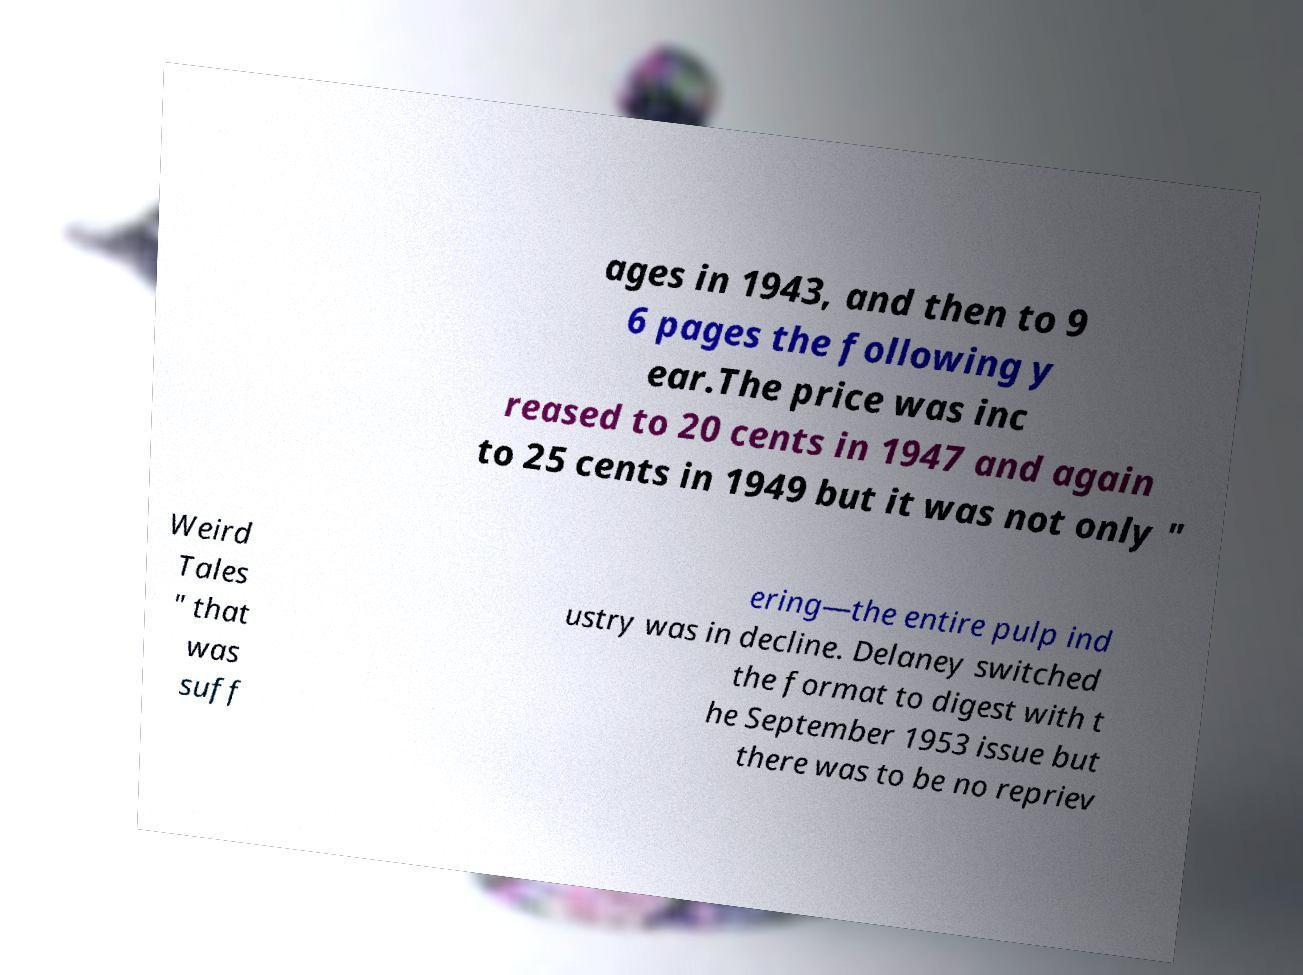Can you read and provide the text displayed in the image?This photo seems to have some interesting text. Can you extract and type it out for me? ages in 1943, and then to 9 6 pages the following y ear.The price was inc reased to 20 cents in 1947 and again to 25 cents in 1949 but it was not only " Weird Tales " that was suff ering—the entire pulp ind ustry was in decline. Delaney switched the format to digest with t he September 1953 issue but there was to be no repriev 